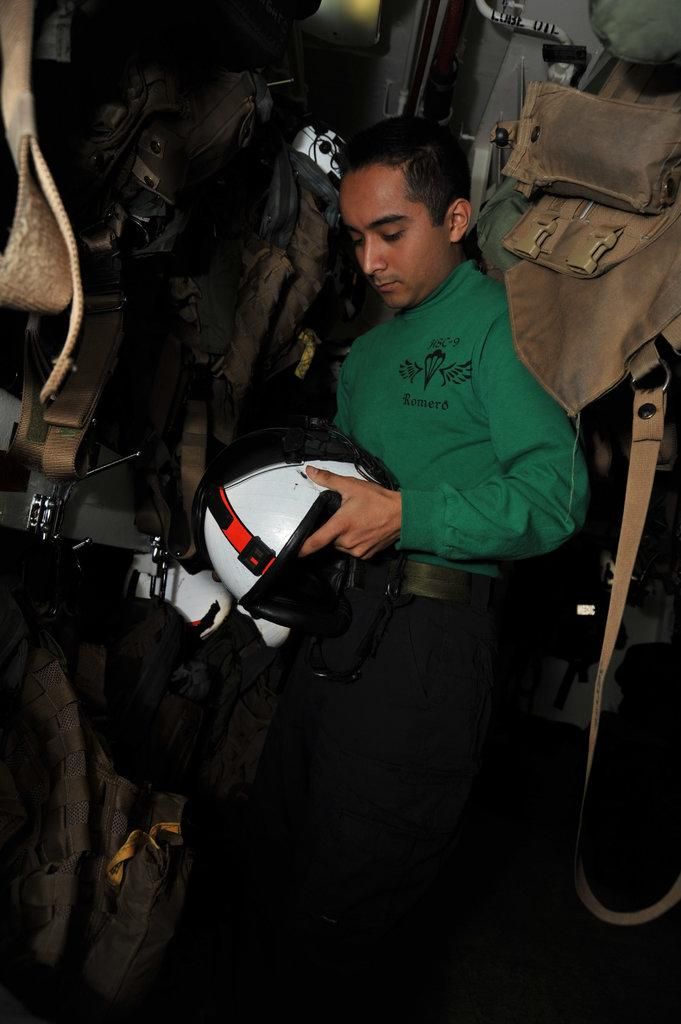What type of clothing is visible in the image? There are jackets in the image. What accessory is being held by the person in the image? The person is holding a helmet in the image. What part of the person's body is connected to the money in the image? There is no money present in the image, so it cannot be connected to any part of the person's body. 